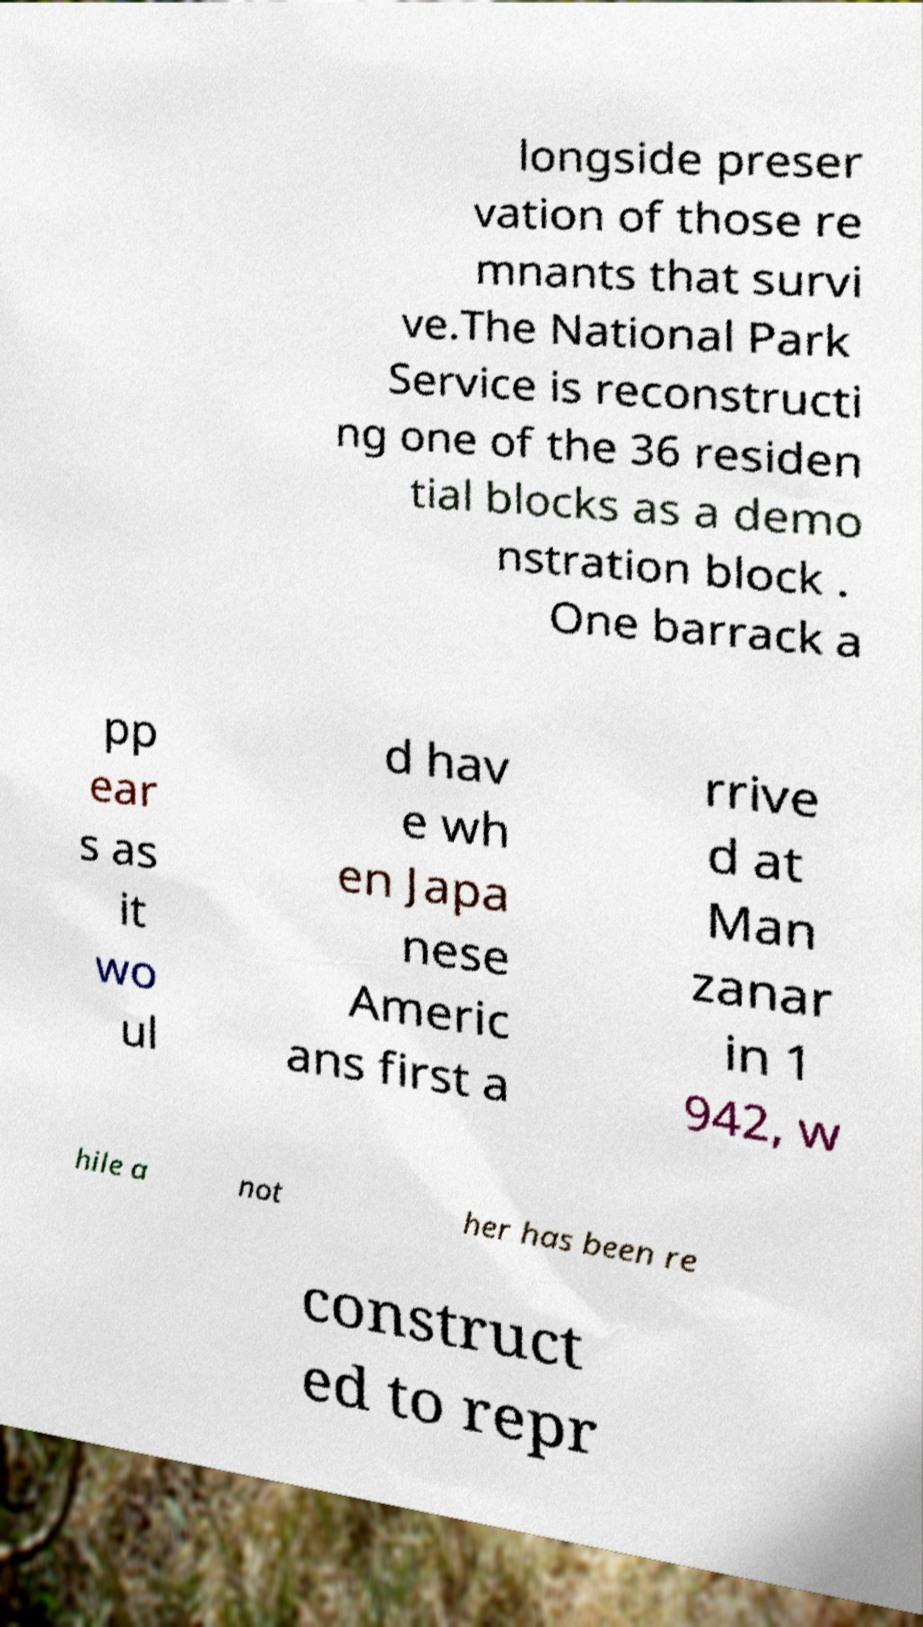I need the written content from this picture converted into text. Can you do that? longside preser vation of those re mnants that survi ve.The National Park Service is reconstructi ng one of the 36 residen tial blocks as a demo nstration block . One barrack a pp ear s as it wo ul d hav e wh en Japa nese Americ ans first a rrive d at Man zanar in 1 942, w hile a not her has been re construct ed to repr 